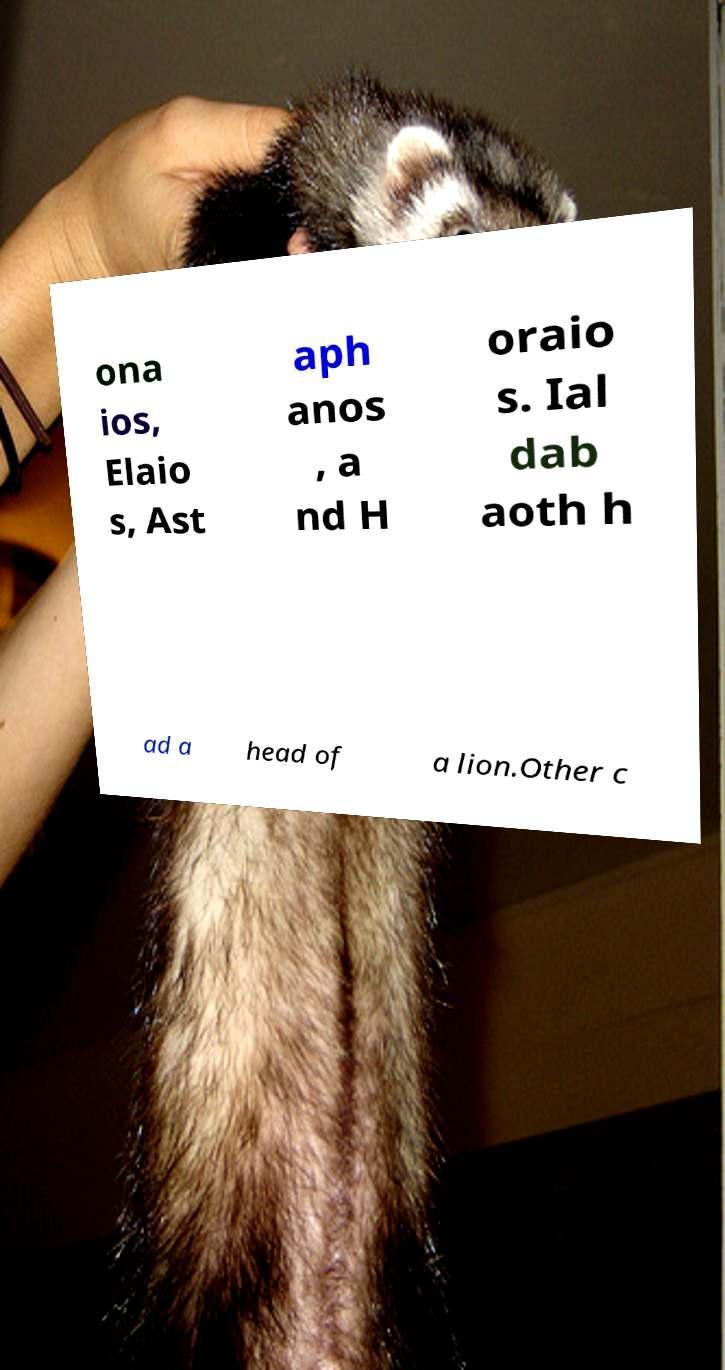Could you assist in decoding the text presented in this image and type it out clearly? ona ios, Elaio s, Ast aph anos , a nd H oraio s. Ial dab aoth h ad a head of a lion.Other c 